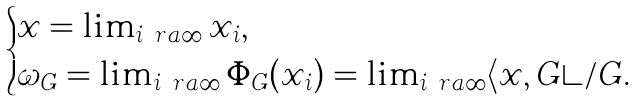Convert formula to latex. <formula><loc_0><loc_0><loc_500><loc_500>\begin{cases} x = \lim _ { i \ r a \infty } x _ { i } , \\ \omega _ { G } = \lim _ { i \ r a \infty } \Phi _ { G } ( x _ { i } ) = \lim _ { i \ r a \infty } \langle x , G \rangle / G . \end{cases}</formula> 